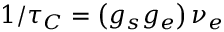<formula> <loc_0><loc_0><loc_500><loc_500>1 / \tau _ { C } = \left ( g _ { s } g _ { e } \right ) \nu _ { e }</formula> 